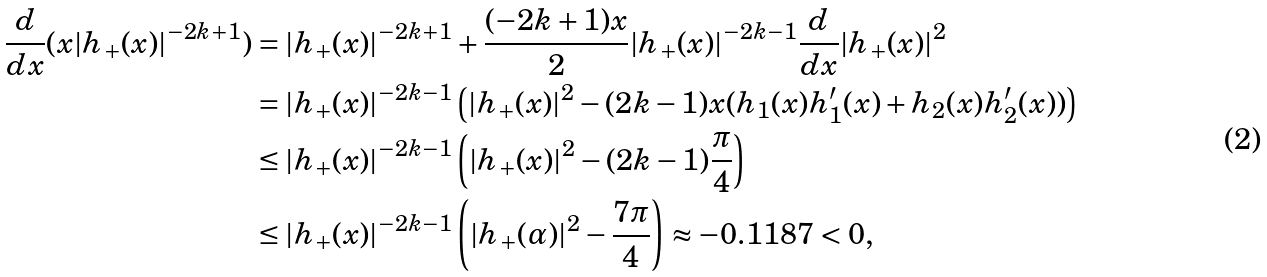<formula> <loc_0><loc_0><loc_500><loc_500>\frac { d } { d x } ( x | h _ { + } ( x ) | ^ { - 2 k + 1 } ) & = | h _ { + } ( x ) | ^ { - 2 k + 1 } + \frac { ( - 2 k + 1 ) x } { 2 } | h _ { + } ( x ) | ^ { - 2 k - 1 } \frac { d } { d x } | h _ { + } ( x ) | ^ { 2 } \\ & = | h _ { + } ( x ) | ^ { - 2 k - 1 } \left ( | h _ { + } ( x ) | ^ { 2 } - ( 2 k - 1 ) x ( h _ { 1 } ( x ) h _ { 1 } ^ { \prime } ( x ) + h _ { 2 } ( x ) h _ { 2 } ^ { \prime } ( x ) ) \right ) \\ & \leq | h _ { + } ( x ) | ^ { - 2 k - 1 } \left ( | h _ { + } ( x ) | ^ { 2 } - ( 2 k - 1 ) \frac { \pi } { 4 } \right ) \\ & \leq | h _ { + } ( x ) | ^ { - 2 k - 1 } \left ( | h _ { + } ( \alpha ) | ^ { 2 } - \frac { 7 \pi } { 4 } \right ) \approx - 0 . 1 1 8 7 < 0 ,</formula> 